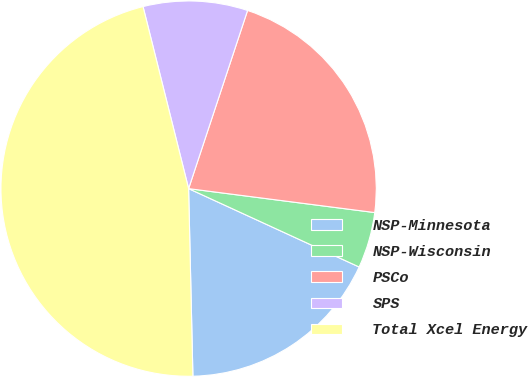Convert chart to OTSL. <chart><loc_0><loc_0><loc_500><loc_500><pie_chart><fcel>NSP-Minnesota<fcel>NSP-Wisconsin<fcel>PSCo<fcel>SPS<fcel>Total Xcel Energy<nl><fcel>17.78%<fcel>4.82%<fcel>21.95%<fcel>8.99%<fcel>46.46%<nl></chart> 